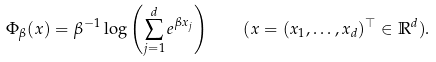<formula> <loc_0><loc_0><loc_500><loc_500>\Phi _ { \beta } ( x ) = \beta ^ { - 1 } \log \left ( \sum _ { j = 1 } ^ { d } e ^ { \beta x _ { j } } \right ) \quad ( x = ( x _ { 1 } , \dots , x _ { d } ) ^ { \top } \in \mathbb { R } ^ { d } ) .</formula> 